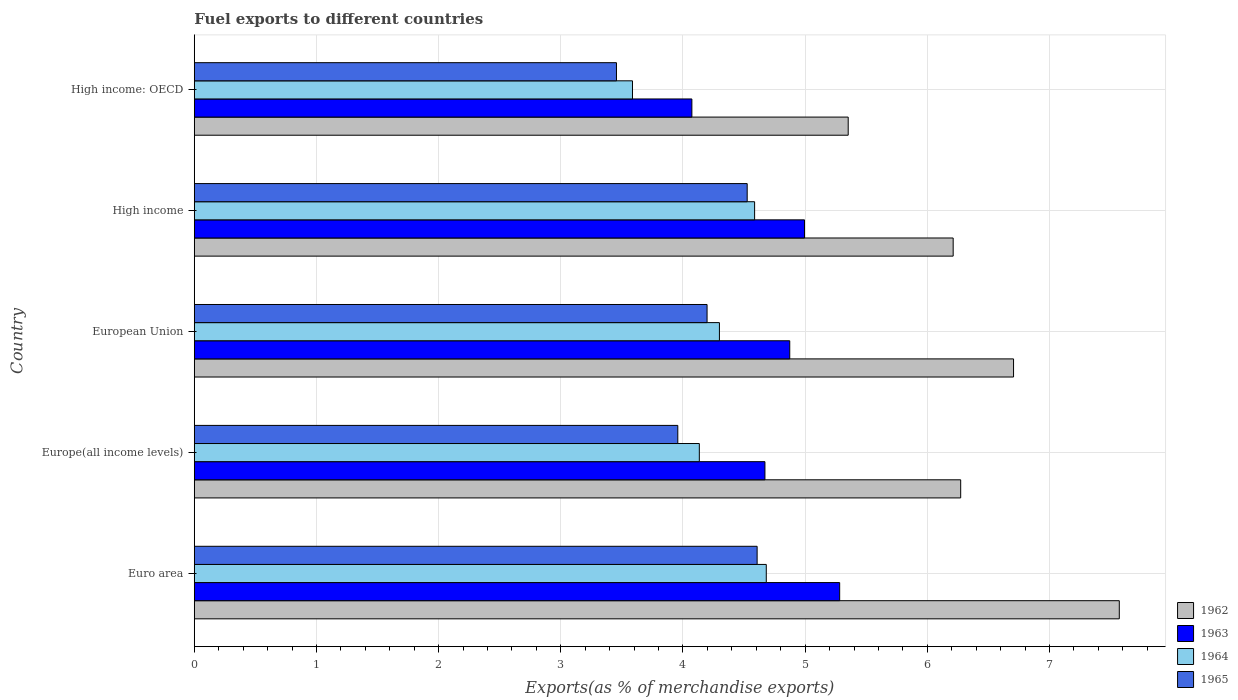How many groups of bars are there?
Your answer should be very brief. 5. Are the number of bars per tick equal to the number of legend labels?
Your answer should be compact. Yes. How many bars are there on the 3rd tick from the top?
Provide a short and direct response. 4. How many bars are there on the 2nd tick from the bottom?
Provide a succinct answer. 4. What is the label of the 1st group of bars from the top?
Make the answer very short. High income: OECD. In how many cases, is the number of bars for a given country not equal to the number of legend labels?
Offer a terse response. 0. What is the percentage of exports to different countries in 1964 in High income: OECD?
Provide a succinct answer. 3.59. Across all countries, what is the maximum percentage of exports to different countries in 1964?
Provide a succinct answer. 4.68. Across all countries, what is the minimum percentage of exports to different countries in 1964?
Offer a terse response. 3.59. In which country was the percentage of exports to different countries in 1965 minimum?
Your answer should be compact. High income: OECD. What is the total percentage of exports to different countries in 1965 in the graph?
Your answer should be compact. 20.74. What is the difference between the percentage of exports to different countries in 1963 in Europe(all income levels) and that in European Union?
Ensure brevity in your answer.  -0.2. What is the difference between the percentage of exports to different countries in 1963 in High income and the percentage of exports to different countries in 1965 in European Union?
Your response must be concise. 0.8. What is the average percentage of exports to different countries in 1964 per country?
Keep it short and to the point. 4.26. What is the difference between the percentage of exports to different countries in 1965 and percentage of exports to different countries in 1962 in Euro area?
Make the answer very short. -2.96. What is the ratio of the percentage of exports to different countries in 1964 in Euro area to that in European Union?
Make the answer very short. 1.09. Is the percentage of exports to different countries in 1963 in Europe(all income levels) less than that in European Union?
Keep it short and to the point. Yes. Is the difference between the percentage of exports to different countries in 1965 in Euro area and High income greater than the difference between the percentage of exports to different countries in 1962 in Euro area and High income?
Provide a short and direct response. No. What is the difference between the highest and the second highest percentage of exports to different countries in 1965?
Provide a succinct answer. 0.08. What is the difference between the highest and the lowest percentage of exports to different countries in 1965?
Offer a terse response. 1.15. In how many countries, is the percentage of exports to different countries in 1962 greater than the average percentage of exports to different countries in 1962 taken over all countries?
Provide a succinct answer. 2. Is the sum of the percentage of exports to different countries in 1964 in European Union and High income greater than the maximum percentage of exports to different countries in 1965 across all countries?
Offer a terse response. Yes. Is it the case that in every country, the sum of the percentage of exports to different countries in 1963 and percentage of exports to different countries in 1964 is greater than the sum of percentage of exports to different countries in 1965 and percentage of exports to different countries in 1962?
Offer a very short reply. No. What does the 2nd bar from the bottom in High income: OECD represents?
Your answer should be compact. 1963. Are all the bars in the graph horizontal?
Your response must be concise. Yes. What is the difference between two consecutive major ticks on the X-axis?
Ensure brevity in your answer.  1. Are the values on the major ticks of X-axis written in scientific E-notation?
Give a very brief answer. No. How many legend labels are there?
Provide a succinct answer. 4. What is the title of the graph?
Keep it short and to the point. Fuel exports to different countries. Does "1973" appear as one of the legend labels in the graph?
Offer a very short reply. No. What is the label or title of the X-axis?
Offer a terse response. Exports(as % of merchandise exports). What is the Exports(as % of merchandise exports) in 1962 in Euro area?
Your answer should be very brief. 7.57. What is the Exports(as % of merchandise exports) in 1963 in Euro area?
Your response must be concise. 5.28. What is the Exports(as % of merchandise exports) in 1964 in Euro area?
Provide a short and direct response. 4.68. What is the Exports(as % of merchandise exports) of 1965 in Euro area?
Make the answer very short. 4.61. What is the Exports(as % of merchandise exports) of 1962 in Europe(all income levels)?
Offer a very short reply. 6.27. What is the Exports(as % of merchandise exports) of 1963 in Europe(all income levels)?
Make the answer very short. 4.67. What is the Exports(as % of merchandise exports) of 1964 in Europe(all income levels)?
Your response must be concise. 4.13. What is the Exports(as % of merchandise exports) of 1965 in Europe(all income levels)?
Offer a terse response. 3.96. What is the Exports(as % of merchandise exports) in 1962 in European Union?
Offer a very short reply. 6.71. What is the Exports(as % of merchandise exports) of 1963 in European Union?
Make the answer very short. 4.87. What is the Exports(as % of merchandise exports) in 1964 in European Union?
Give a very brief answer. 4.3. What is the Exports(as % of merchandise exports) of 1965 in European Union?
Provide a short and direct response. 4.2. What is the Exports(as % of merchandise exports) in 1962 in High income?
Keep it short and to the point. 6.21. What is the Exports(as % of merchandise exports) in 1963 in High income?
Ensure brevity in your answer.  5. What is the Exports(as % of merchandise exports) of 1964 in High income?
Your answer should be very brief. 4.59. What is the Exports(as % of merchandise exports) in 1965 in High income?
Keep it short and to the point. 4.53. What is the Exports(as % of merchandise exports) in 1962 in High income: OECD?
Keep it short and to the point. 5.35. What is the Exports(as % of merchandise exports) of 1963 in High income: OECD?
Offer a terse response. 4.07. What is the Exports(as % of merchandise exports) in 1964 in High income: OECD?
Offer a terse response. 3.59. What is the Exports(as % of merchandise exports) in 1965 in High income: OECD?
Your answer should be very brief. 3.46. Across all countries, what is the maximum Exports(as % of merchandise exports) of 1962?
Provide a short and direct response. 7.57. Across all countries, what is the maximum Exports(as % of merchandise exports) of 1963?
Give a very brief answer. 5.28. Across all countries, what is the maximum Exports(as % of merchandise exports) of 1964?
Your answer should be very brief. 4.68. Across all countries, what is the maximum Exports(as % of merchandise exports) in 1965?
Offer a very short reply. 4.61. Across all countries, what is the minimum Exports(as % of merchandise exports) in 1962?
Ensure brevity in your answer.  5.35. Across all countries, what is the minimum Exports(as % of merchandise exports) in 1963?
Provide a short and direct response. 4.07. Across all countries, what is the minimum Exports(as % of merchandise exports) in 1964?
Offer a terse response. 3.59. Across all countries, what is the minimum Exports(as % of merchandise exports) of 1965?
Your answer should be compact. 3.46. What is the total Exports(as % of merchandise exports) of 1962 in the graph?
Provide a succinct answer. 32.12. What is the total Exports(as % of merchandise exports) of 1963 in the graph?
Offer a very short reply. 23.9. What is the total Exports(as % of merchandise exports) of 1964 in the graph?
Offer a very short reply. 21.29. What is the total Exports(as % of merchandise exports) in 1965 in the graph?
Your answer should be compact. 20.74. What is the difference between the Exports(as % of merchandise exports) of 1962 in Euro area and that in Europe(all income levels)?
Offer a very short reply. 1.3. What is the difference between the Exports(as % of merchandise exports) of 1963 in Euro area and that in Europe(all income levels)?
Ensure brevity in your answer.  0.61. What is the difference between the Exports(as % of merchandise exports) in 1964 in Euro area and that in Europe(all income levels)?
Your answer should be very brief. 0.55. What is the difference between the Exports(as % of merchandise exports) of 1965 in Euro area and that in Europe(all income levels)?
Offer a terse response. 0.65. What is the difference between the Exports(as % of merchandise exports) of 1962 in Euro area and that in European Union?
Give a very brief answer. 0.87. What is the difference between the Exports(as % of merchandise exports) of 1963 in Euro area and that in European Union?
Provide a succinct answer. 0.41. What is the difference between the Exports(as % of merchandise exports) of 1964 in Euro area and that in European Union?
Offer a very short reply. 0.38. What is the difference between the Exports(as % of merchandise exports) of 1965 in Euro area and that in European Union?
Your answer should be compact. 0.41. What is the difference between the Exports(as % of merchandise exports) of 1962 in Euro area and that in High income?
Keep it short and to the point. 1.36. What is the difference between the Exports(as % of merchandise exports) of 1963 in Euro area and that in High income?
Make the answer very short. 0.29. What is the difference between the Exports(as % of merchandise exports) in 1964 in Euro area and that in High income?
Offer a terse response. 0.1. What is the difference between the Exports(as % of merchandise exports) of 1965 in Euro area and that in High income?
Your response must be concise. 0.08. What is the difference between the Exports(as % of merchandise exports) in 1962 in Euro area and that in High income: OECD?
Your response must be concise. 2.22. What is the difference between the Exports(as % of merchandise exports) of 1963 in Euro area and that in High income: OECD?
Keep it short and to the point. 1.21. What is the difference between the Exports(as % of merchandise exports) in 1964 in Euro area and that in High income: OECD?
Give a very brief answer. 1.1. What is the difference between the Exports(as % of merchandise exports) in 1965 in Euro area and that in High income: OECD?
Provide a short and direct response. 1.15. What is the difference between the Exports(as % of merchandise exports) of 1962 in Europe(all income levels) and that in European Union?
Your answer should be very brief. -0.43. What is the difference between the Exports(as % of merchandise exports) of 1963 in Europe(all income levels) and that in European Union?
Offer a terse response. -0.2. What is the difference between the Exports(as % of merchandise exports) of 1964 in Europe(all income levels) and that in European Union?
Offer a terse response. -0.16. What is the difference between the Exports(as % of merchandise exports) of 1965 in Europe(all income levels) and that in European Union?
Provide a succinct answer. -0.24. What is the difference between the Exports(as % of merchandise exports) of 1962 in Europe(all income levels) and that in High income?
Your response must be concise. 0.06. What is the difference between the Exports(as % of merchandise exports) of 1963 in Europe(all income levels) and that in High income?
Give a very brief answer. -0.32. What is the difference between the Exports(as % of merchandise exports) of 1964 in Europe(all income levels) and that in High income?
Keep it short and to the point. -0.45. What is the difference between the Exports(as % of merchandise exports) of 1965 in Europe(all income levels) and that in High income?
Ensure brevity in your answer.  -0.57. What is the difference between the Exports(as % of merchandise exports) in 1962 in Europe(all income levels) and that in High income: OECD?
Offer a terse response. 0.92. What is the difference between the Exports(as % of merchandise exports) of 1963 in Europe(all income levels) and that in High income: OECD?
Ensure brevity in your answer.  0.6. What is the difference between the Exports(as % of merchandise exports) of 1964 in Europe(all income levels) and that in High income: OECD?
Ensure brevity in your answer.  0.55. What is the difference between the Exports(as % of merchandise exports) of 1965 in Europe(all income levels) and that in High income: OECD?
Give a very brief answer. 0.5. What is the difference between the Exports(as % of merchandise exports) of 1962 in European Union and that in High income?
Your answer should be compact. 0.49. What is the difference between the Exports(as % of merchandise exports) in 1963 in European Union and that in High income?
Offer a very short reply. -0.12. What is the difference between the Exports(as % of merchandise exports) of 1964 in European Union and that in High income?
Provide a succinct answer. -0.29. What is the difference between the Exports(as % of merchandise exports) in 1965 in European Union and that in High income?
Give a very brief answer. -0.33. What is the difference between the Exports(as % of merchandise exports) of 1962 in European Union and that in High income: OECD?
Your answer should be compact. 1.35. What is the difference between the Exports(as % of merchandise exports) of 1963 in European Union and that in High income: OECD?
Make the answer very short. 0.8. What is the difference between the Exports(as % of merchandise exports) in 1964 in European Union and that in High income: OECD?
Your response must be concise. 0.71. What is the difference between the Exports(as % of merchandise exports) in 1965 in European Union and that in High income: OECD?
Make the answer very short. 0.74. What is the difference between the Exports(as % of merchandise exports) of 1962 in High income and that in High income: OECD?
Provide a succinct answer. 0.86. What is the difference between the Exports(as % of merchandise exports) of 1963 in High income and that in High income: OECD?
Keep it short and to the point. 0.92. What is the difference between the Exports(as % of merchandise exports) in 1965 in High income and that in High income: OECD?
Make the answer very short. 1.07. What is the difference between the Exports(as % of merchandise exports) in 1962 in Euro area and the Exports(as % of merchandise exports) in 1963 in Europe(all income levels)?
Your answer should be compact. 2.9. What is the difference between the Exports(as % of merchandise exports) in 1962 in Euro area and the Exports(as % of merchandise exports) in 1964 in Europe(all income levels)?
Provide a short and direct response. 3.44. What is the difference between the Exports(as % of merchandise exports) in 1962 in Euro area and the Exports(as % of merchandise exports) in 1965 in Europe(all income levels)?
Make the answer very short. 3.61. What is the difference between the Exports(as % of merchandise exports) in 1963 in Euro area and the Exports(as % of merchandise exports) in 1964 in Europe(all income levels)?
Make the answer very short. 1.15. What is the difference between the Exports(as % of merchandise exports) of 1963 in Euro area and the Exports(as % of merchandise exports) of 1965 in Europe(all income levels)?
Provide a succinct answer. 1.32. What is the difference between the Exports(as % of merchandise exports) of 1964 in Euro area and the Exports(as % of merchandise exports) of 1965 in Europe(all income levels)?
Provide a short and direct response. 0.72. What is the difference between the Exports(as % of merchandise exports) of 1962 in Euro area and the Exports(as % of merchandise exports) of 1963 in European Union?
Give a very brief answer. 2.7. What is the difference between the Exports(as % of merchandise exports) in 1962 in Euro area and the Exports(as % of merchandise exports) in 1964 in European Union?
Ensure brevity in your answer.  3.27. What is the difference between the Exports(as % of merchandise exports) in 1962 in Euro area and the Exports(as % of merchandise exports) in 1965 in European Union?
Your response must be concise. 3.37. What is the difference between the Exports(as % of merchandise exports) in 1963 in Euro area and the Exports(as % of merchandise exports) in 1964 in European Union?
Provide a succinct answer. 0.98. What is the difference between the Exports(as % of merchandise exports) in 1963 in Euro area and the Exports(as % of merchandise exports) in 1965 in European Union?
Ensure brevity in your answer.  1.09. What is the difference between the Exports(as % of merchandise exports) in 1964 in Euro area and the Exports(as % of merchandise exports) in 1965 in European Union?
Your answer should be very brief. 0.48. What is the difference between the Exports(as % of merchandise exports) in 1962 in Euro area and the Exports(as % of merchandise exports) in 1963 in High income?
Make the answer very short. 2.58. What is the difference between the Exports(as % of merchandise exports) of 1962 in Euro area and the Exports(as % of merchandise exports) of 1964 in High income?
Make the answer very short. 2.98. What is the difference between the Exports(as % of merchandise exports) of 1962 in Euro area and the Exports(as % of merchandise exports) of 1965 in High income?
Offer a very short reply. 3.05. What is the difference between the Exports(as % of merchandise exports) of 1963 in Euro area and the Exports(as % of merchandise exports) of 1964 in High income?
Your answer should be very brief. 0.7. What is the difference between the Exports(as % of merchandise exports) in 1963 in Euro area and the Exports(as % of merchandise exports) in 1965 in High income?
Give a very brief answer. 0.76. What is the difference between the Exports(as % of merchandise exports) of 1964 in Euro area and the Exports(as % of merchandise exports) of 1965 in High income?
Offer a very short reply. 0.16. What is the difference between the Exports(as % of merchandise exports) in 1962 in Euro area and the Exports(as % of merchandise exports) in 1963 in High income: OECD?
Your answer should be compact. 3.5. What is the difference between the Exports(as % of merchandise exports) of 1962 in Euro area and the Exports(as % of merchandise exports) of 1964 in High income: OECD?
Your response must be concise. 3.98. What is the difference between the Exports(as % of merchandise exports) of 1962 in Euro area and the Exports(as % of merchandise exports) of 1965 in High income: OECD?
Provide a short and direct response. 4.12. What is the difference between the Exports(as % of merchandise exports) in 1963 in Euro area and the Exports(as % of merchandise exports) in 1964 in High income: OECD?
Offer a very short reply. 1.7. What is the difference between the Exports(as % of merchandise exports) in 1963 in Euro area and the Exports(as % of merchandise exports) in 1965 in High income: OECD?
Make the answer very short. 1.83. What is the difference between the Exports(as % of merchandise exports) of 1964 in Euro area and the Exports(as % of merchandise exports) of 1965 in High income: OECD?
Keep it short and to the point. 1.23. What is the difference between the Exports(as % of merchandise exports) of 1962 in Europe(all income levels) and the Exports(as % of merchandise exports) of 1963 in European Union?
Give a very brief answer. 1.4. What is the difference between the Exports(as % of merchandise exports) in 1962 in Europe(all income levels) and the Exports(as % of merchandise exports) in 1964 in European Union?
Provide a succinct answer. 1.97. What is the difference between the Exports(as % of merchandise exports) in 1962 in Europe(all income levels) and the Exports(as % of merchandise exports) in 1965 in European Union?
Make the answer very short. 2.08. What is the difference between the Exports(as % of merchandise exports) of 1963 in Europe(all income levels) and the Exports(as % of merchandise exports) of 1964 in European Union?
Your answer should be very brief. 0.37. What is the difference between the Exports(as % of merchandise exports) of 1963 in Europe(all income levels) and the Exports(as % of merchandise exports) of 1965 in European Union?
Keep it short and to the point. 0.47. What is the difference between the Exports(as % of merchandise exports) in 1964 in Europe(all income levels) and the Exports(as % of merchandise exports) in 1965 in European Union?
Your answer should be compact. -0.06. What is the difference between the Exports(as % of merchandise exports) of 1962 in Europe(all income levels) and the Exports(as % of merchandise exports) of 1963 in High income?
Ensure brevity in your answer.  1.28. What is the difference between the Exports(as % of merchandise exports) of 1962 in Europe(all income levels) and the Exports(as % of merchandise exports) of 1964 in High income?
Provide a succinct answer. 1.69. What is the difference between the Exports(as % of merchandise exports) of 1962 in Europe(all income levels) and the Exports(as % of merchandise exports) of 1965 in High income?
Provide a succinct answer. 1.75. What is the difference between the Exports(as % of merchandise exports) of 1963 in Europe(all income levels) and the Exports(as % of merchandise exports) of 1964 in High income?
Provide a short and direct response. 0.08. What is the difference between the Exports(as % of merchandise exports) in 1963 in Europe(all income levels) and the Exports(as % of merchandise exports) in 1965 in High income?
Keep it short and to the point. 0.15. What is the difference between the Exports(as % of merchandise exports) of 1964 in Europe(all income levels) and the Exports(as % of merchandise exports) of 1965 in High income?
Make the answer very short. -0.39. What is the difference between the Exports(as % of merchandise exports) in 1962 in Europe(all income levels) and the Exports(as % of merchandise exports) in 1963 in High income: OECD?
Your answer should be compact. 2.2. What is the difference between the Exports(as % of merchandise exports) in 1962 in Europe(all income levels) and the Exports(as % of merchandise exports) in 1964 in High income: OECD?
Provide a short and direct response. 2.69. What is the difference between the Exports(as % of merchandise exports) in 1962 in Europe(all income levels) and the Exports(as % of merchandise exports) in 1965 in High income: OECD?
Provide a short and direct response. 2.82. What is the difference between the Exports(as % of merchandise exports) in 1963 in Europe(all income levels) and the Exports(as % of merchandise exports) in 1964 in High income: OECD?
Offer a very short reply. 1.08. What is the difference between the Exports(as % of merchandise exports) of 1963 in Europe(all income levels) and the Exports(as % of merchandise exports) of 1965 in High income: OECD?
Provide a short and direct response. 1.22. What is the difference between the Exports(as % of merchandise exports) of 1964 in Europe(all income levels) and the Exports(as % of merchandise exports) of 1965 in High income: OECD?
Offer a terse response. 0.68. What is the difference between the Exports(as % of merchandise exports) in 1962 in European Union and the Exports(as % of merchandise exports) in 1963 in High income?
Provide a succinct answer. 1.71. What is the difference between the Exports(as % of merchandise exports) in 1962 in European Union and the Exports(as % of merchandise exports) in 1964 in High income?
Ensure brevity in your answer.  2.12. What is the difference between the Exports(as % of merchandise exports) in 1962 in European Union and the Exports(as % of merchandise exports) in 1965 in High income?
Offer a very short reply. 2.18. What is the difference between the Exports(as % of merchandise exports) in 1963 in European Union and the Exports(as % of merchandise exports) in 1964 in High income?
Ensure brevity in your answer.  0.29. What is the difference between the Exports(as % of merchandise exports) in 1963 in European Union and the Exports(as % of merchandise exports) in 1965 in High income?
Make the answer very short. 0.35. What is the difference between the Exports(as % of merchandise exports) of 1964 in European Union and the Exports(as % of merchandise exports) of 1965 in High income?
Provide a short and direct response. -0.23. What is the difference between the Exports(as % of merchandise exports) of 1962 in European Union and the Exports(as % of merchandise exports) of 1963 in High income: OECD?
Keep it short and to the point. 2.63. What is the difference between the Exports(as % of merchandise exports) of 1962 in European Union and the Exports(as % of merchandise exports) of 1964 in High income: OECD?
Offer a terse response. 3.12. What is the difference between the Exports(as % of merchandise exports) of 1962 in European Union and the Exports(as % of merchandise exports) of 1965 in High income: OECD?
Make the answer very short. 3.25. What is the difference between the Exports(as % of merchandise exports) in 1963 in European Union and the Exports(as % of merchandise exports) in 1964 in High income: OECD?
Make the answer very short. 1.29. What is the difference between the Exports(as % of merchandise exports) in 1963 in European Union and the Exports(as % of merchandise exports) in 1965 in High income: OECD?
Offer a very short reply. 1.42. What is the difference between the Exports(as % of merchandise exports) of 1964 in European Union and the Exports(as % of merchandise exports) of 1965 in High income: OECD?
Offer a terse response. 0.84. What is the difference between the Exports(as % of merchandise exports) of 1962 in High income and the Exports(as % of merchandise exports) of 1963 in High income: OECD?
Keep it short and to the point. 2.14. What is the difference between the Exports(as % of merchandise exports) in 1962 in High income and the Exports(as % of merchandise exports) in 1964 in High income: OECD?
Your answer should be compact. 2.62. What is the difference between the Exports(as % of merchandise exports) of 1962 in High income and the Exports(as % of merchandise exports) of 1965 in High income: OECD?
Your response must be concise. 2.76. What is the difference between the Exports(as % of merchandise exports) of 1963 in High income and the Exports(as % of merchandise exports) of 1964 in High income: OECD?
Give a very brief answer. 1.41. What is the difference between the Exports(as % of merchandise exports) in 1963 in High income and the Exports(as % of merchandise exports) in 1965 in High income: OECD?
Your answer should be very brief. 1.54. What is the difference between the Exports(as % of merchandise exports) of 1964 in High income and the Exports(as % of merchandise exports) of 1965 in High income: OECD?
Offer a terse response. 1.13. What is the average Exports(as % of merchandise exports) in 1962 per country?
Your answer should be very brief. 6.42. What is the average Exports(as % of merchandise exports) of 1963 per country?
Your answer should be very brief. 4.78. What is the average Exports(as % of merchandise exports) in 1964 per country?
Your answer should be compact. 4.26. What is the average Exports(as % of merchandise exports) of 1965 per country?
Keep it short and to the point. 4.15. What is the difference between the Exports(as % of merchandise exports) of 1962 and Exports(as % of merchandise exports) of 1963 in Euro area?
Your answer should be compact. 2.29. What is the difference between the Exports(as % of merchandise exports) of 1962 and Exports(as % of merchandise exports) of 1964 in Euro area?
Your response must be concise. 2.89. What is the difference between the Exports(as % of merchandise exports) of 1962 and Exports(as % of merchandise exports) of 1965 in Euro area?
Provide a short and direct response. 2.96. What is the difference between the Exports(as % of merchandise exports) in 1963 and Exports(as % of merchandise exports) in 1964 in Euro area?
Your response must be concise. 0.6. What is the difference between the Exports(as % of merchandise exports) of 1963 and Exports(as % of merchandise exports) of 1965 in Euro area?
Give a very brief answer. 0.68. What is the difference between the Exports(as % of merchandise exports) in 1964 and Exports(as % of merchandise exports) in 1965 in Euro area?
Your response must be concise. 0.07. What is the difference between the Exports(as % of merchandise exports) in 1962 and Exports(as % of merchandise exports) in 1963 in Europe(all income levels)?
Give a very brief answer. 1.6. What is the difference between the Exports(as % of merchandise exports) of 1962 and Exports(as % of merchandise exports) of 1964 in Europe(all income levels)?
Ensure brevity in your answer.  2.14. What is the difference between the Exports(as % of merchandise exports) of 1962 and Exports(as % of merchandise exports) of 1965 in Europe(all income levels)?
Provide a succinct answer. 2.32. What is the difference between the Exports(as % of merchandise exports) of 1963 and Exports(as % of merchandise exports) of 1964 in Europe(all income levels)?
Provide a succinct answer. 0.54. What is the difference between the Exports(as % of merchandise exports) in 1963 and Exports(as % of merchandise exports) in 1965 in Europe(all income levels)?
Ensure brevity in your answer.  0.71. What is the difference between the Exports(as % of merchandise exports) in 1964 and Exports(as % of merchandise exports) in 1965 in Europe(all income levels)?
Make the answer very short. 0.18. What is the difference between the Exports(as % of merchandise exports) of 1962 and Exports(as % of merchandise exports) of 1963 in European Union?
Offer a very short reply. 1.83. What is the difference between the Exports(as % of merchandise exports) in 1962 and Exports(as % of merchandise exports) in 1964 in European Union?
Provide a short and direct response. 2.41. What is the difference between the Exports(as % of merchandise exports) in 1962 and Exports(as % of merchandise exports) in 1965 in European Union?
Ensure brevity in your answer.  2.51. What is the difference between the Exports(as % of merchandise exports) of 1963 and Exports(as % of merchandise exports) of 1964 in European Union?
Your answer should be compact. 0.58. What is the difference between the Exports(as % of merchandise exports) in 1963 and Exports(as % of merchandise exports) in 1965 in European Union?
Keep it short and to the point. 0.68. What is the difference between the Exports(as % of merchandise exports) of 1964 and Exports(as % of merchandise exports) of 1965 in European Union?
Provide a succinct answer. 0.1. What is the difference between the Exports(as % of merchandise exports) of 1962 and Exports(as % of merchandise exports) of 1963 in High income?
Offer a very short reply. 1.22. What is the difference between the Exports(as % of merchandise exports) of 1962 and Exports(as % of merchandise exports) of 1964 in High income?
Provide a short and direct response. 1.63. What is the difference between the Exports(as % of merchandise exports) in 1962 and Exports(as % of merchandise exports) in 1965 in High income?
Give a very brief answer. 1.69. What is the difference between the Exports(as % of merchandise exports) of 1963 and Exports(as % of merchandise exports) of 1964 in High income?
Keep it short and to the point. 0.41. What is the difference between the Exports(as % of merchandise exports) in 1963 and Exports(as % of merchandise exports) in 1965 in High income?
Give a very brief answer. 0.47. What is the difference between the Exports(as % of merchandise exports) of 1964 and Exports(as % of merchandise exports) of 1965 in High income?
Your answer should be compact. 0.06. What is the difference between the Exports(as % of merchandise exports) of 1962 and Exports(as % of merchandise exports) of 1963 in High income: OECD?
Provide a short and direct response. 1.28. What is the difference between the Exports(as % of merchandise exports) in 1962 and Exports(as % of merchandise exports) in 1964 in High income: OECD?
Give a very brief answer. 1.77. What is the difference between the Exports(as % of merchandise exports) of 1962 and Exports(as % of merchandise exports) of 1965 in High income: OECD?
Give a very brief answer. 1.9. What is the difference between the Exports(as % of merchandise exports) of 1963 and Exports(as % of merchandise exports) of 1964 in High income: OECD?
Offer a very short reply. 0.49. What is the difference between the Exports(as % of merchandise exports) in 1963 and Exports(as % of merchandise exports) in 1965 in High income: OECD?
Provide a short and direct response. 0.62. What is the difference between the Exports(as % of merchandise exports) in 1964 and Exports(as % of merchandise exports) in 1965 in High income: OECD?
Your answer should be very brief. 0.13. What is the ratio of the Exports(as % of merchandise exports) of 1962 in Euro area to that in Europe(all income levels)?
Give a very brief answer. 1.21. What is the ratio of the Exports(as % of merchandise exports) in 1963 in Euro area to that in Europe(all income levels)?
Provide a succinct answer. 1.13. What is the ratio of the Exports(as % of merchandise exports) in 1964 in Euro area to that in Europe(all income levels)?
Keep it short and to the point. 1.13. What is the ratio of the Exports(as % of merchandise exports) of 1965 in Euro area to that in Europe(all income levels)?
Provide a succinct answer. 1.16. What is the ratio of the Exports(as % of merchandise exports) in 1962 in Euro area to that in European Union?
Give a very brief answer. 1.13. What is the ratio of the Exports(as % of merchandise exports) in 1963 in Euro area to that in European Union?
Your answer should be very brief. 1.08. What is the ratio of the Exports(as % of merchandise exports) in 1964 in Euro area to that in European Union?
Your answer should be very brief. 1.09. What is the ratio of the Exports(as % of merchandise exports) of 1965 in Euro area to that in European Union?
Offer a very short reply. 1.1. What is the ratio of the Exports(as % of merchandise exports) in 1962 in Euro area to that in High income?
Offer a very short reply. 1.22. What is the ratio of the Exports(as % of merchandise exports) of 1963 in Euro area to that in High income?
Your response must be concise. 1.06. What is the ratio of the Exports(as % of merchandise exports) in 1964 in Euro area to that in High income?
Keep it short and to the point. 1.02. What is the ratio of the Exports(as % of merchandise exports) of 1965 in Euro area to that in High income?
Your answer should be very brief. 1.02. What is the ratio of the Exports(as % of merchandise exports) of 1962 in Euro area to that in High income: OECD?
Offer a very short reply. 1.41. What is the ratio of the Exports(as % of merchandise exports) of 1963 in Euro area to that in High income: OECD?
Your response must be concise. 1.3. What is the ratio of the Exports(as % of merchandise exports) in 1964 in Euro area to that in High income: OECD?
Offer a very short reply. 1.31. What is the ratio of the Exports(as % of merchandise exports) of 1965 in Euro area to that in High income: OECD?
Your answer should be compact. 1.33. What is the ratio of the Exports(as % of merchandise exports) in 1962 in Europe(all income levels) to that in European Union?
Keep it short and to the point. 0.94. What is the ratio of the Exports(as % of merchandise exports) of 1964 in Europe(all income levels) to that in European Union?
Keep it short and to the point. 0.96. What is the ratio of the Exports(as % of merchandise exports) in 1965 in Europe(all income levels) to that in European Union?
Ensure brevity in your answer.  0.94. What is the ratio of the Exports(as % of merchandise exports) in 1962 in Europe(all income levels) to that in High income?
Provide a succinct answer. 1.01. What is the ratio of the Exports(as % of merchandise exports) of 1963 in Europe(all income levels) to that in High income?
Ensure brevity in your answer.  0.94. What is the ratio of the Exports(as % of merchandise exports) of 1964 in Europe(all income levels) to that in High income?
Make the answer very short. 0.9. What is the ratio of the Exports(as % of merchandise exports) of 1965 in Europe(all income levels) to that in High income?
Provide a succinct answer. 0.87. What is the ratio of the Exports(as % of merchandise exports) of 1962 in Europe(all income levels) to that in High income: OECD?
Offer a terse response. 1.17. What is the ratio of the Exports(as % of merchandise exports) in 1963 in Europe(all income levels) to that in High income: OECD?
Your answer should be very brief. 1.15. What is the ratio of the Exports(as % of merchandise exports) of 1964 in Europe(all income levels) to that in High income: OECD?
Your answer should be very brief. 1.15. What is the ratio of the Exports(as % of merchandise exports) of 1965 in Europe(all income levels) to that in High income: OECD?
Your answer should be compact. 1.15. What is the ratio of the Exports(as % of merchandise exports) of 1962 in European Union to that in High income?
Give a very brief answer. 1.08. What is the ratio of the Exports(as % of merchandise exports) of 1963 in European Union to that in High income?
Give a very brief answer. 0.98. What is the ratio of the Exports(as % of merchandise exports) of 1964 in European Union to that in High income?
Your answer should be compact. 0.94. What is the ratio of the Exports(as % of merchandise exports) of 1965 in European Union to that in High income?
Offer a very short reply. 0.93. What is the ratio of the Exports(as % of merchandise exports) of 1962 in European Union to that in High income: OECD?
Your answer should be compact. 1.25. What is the ratio of the Exports(as % of merchandise exports) of 1963 in European Union to that in High income: OECD?
Make the answer very short. 1.2. What is the ratio of the Exports(as % of merchandise exports) of 1964 in European Union to that in High income: OECD?
Keep it short and to the point. 1.2. What is the ratio of the Exports(as % of merchandise exports) of 1965 in European Union to that in High income: OECD?
Keep it short and to the point. 1.21. What is the ratio of the Exports(as % of merchandise exports) of 1962 in High income to that in High income: OECD?
Provide a short and direct response. 1.16. What is the ratio of the Exports(as % of merchandise exports) in 1963 in High income to that in High income: OECD?
Offer a terse response. 1.23. What is the ratio of the Exports(as % of merchandise exports) of 1964 in High income to that in High income: OECD?
Your answer should be very brief. 1.28. What is the ratio of the Exports(as % of merchandise exports) of 1965 in High income to that in High income: OECD?
Keep it short and to the point. 1.31. What is the difference between the highest and the second highest Exports(as % of merchandise exports) in 1962?
Make the answer very short. 0.87. What is the difference between the highest and the second highest Exports(as % of merchandise exports) in 1963?
Your response must be concise. 0.29. What is the difference between the highest and the second highest Exports(as % of merchandise exports) in 1964?
Your answer should be very brief. 0.1. What is the difference between the highest and the second highest Exports(as % of merchandise exports) in 1965?
Your response must be concise. 0.08. What is the difference between the highest and the lowest Exports(as % of merchandise exports) in 1962?
Make the answer very short. 2.22. What is the difference between the highest and the lowest Exports(as % of merchandise exports) in 1963?
Provide a succinct answer. 1.21. What is the difference between the highest and the lowest Exports(as % of merchandise exports) in 1964?
Provide a short and direct response. 1.1. What is the difference between the highest and the lowest Exports(as % of merchandise exports) of 1965?
Provide a short and direct response. 1.15. 